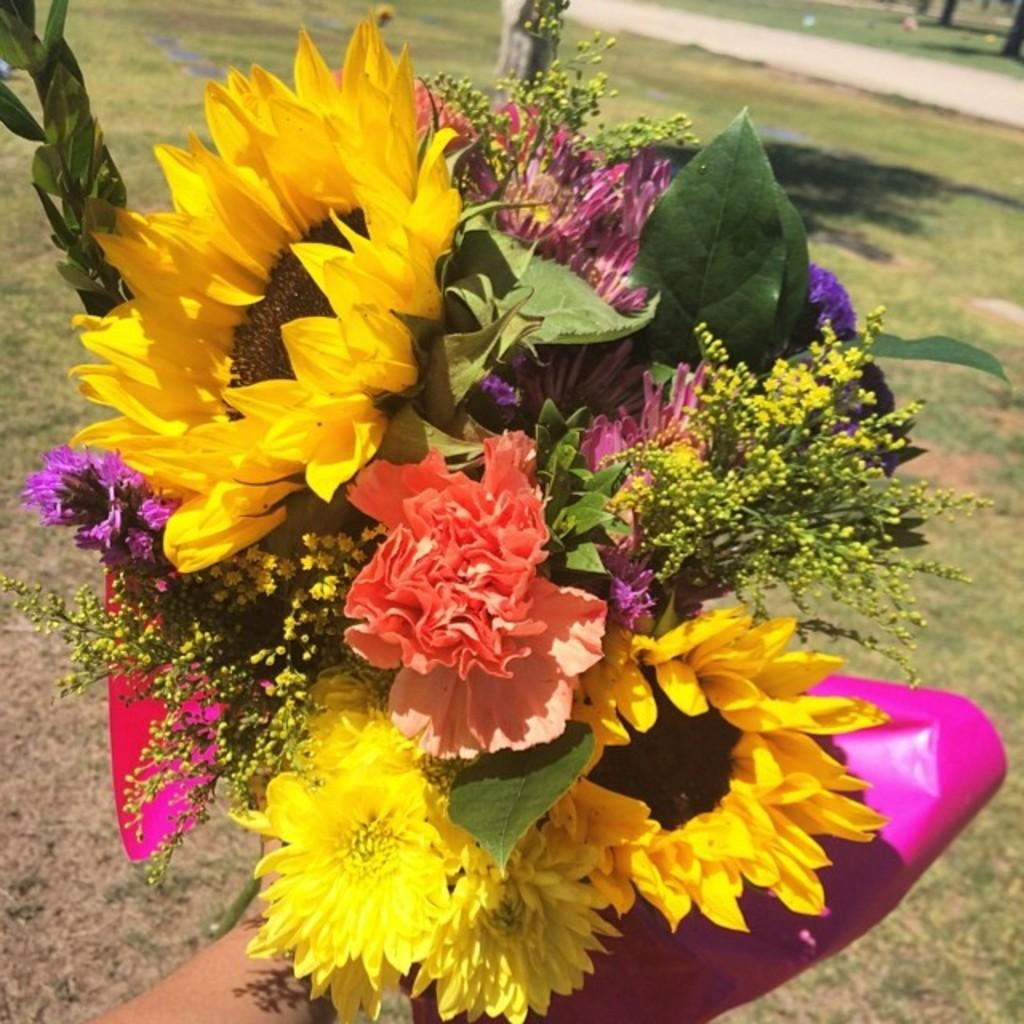What is the main subject of the image? There is a person in the image. What is the person holding in the image? The person is holding a bouquet. What type of surface is visible at the bottom of the image? There is grass at the bottom of the image. How would you describe the background of the image? The background of the image is blurred. Can you hear the bell ringing in the image? There is no bell present in the image, so it cannot be heard. 